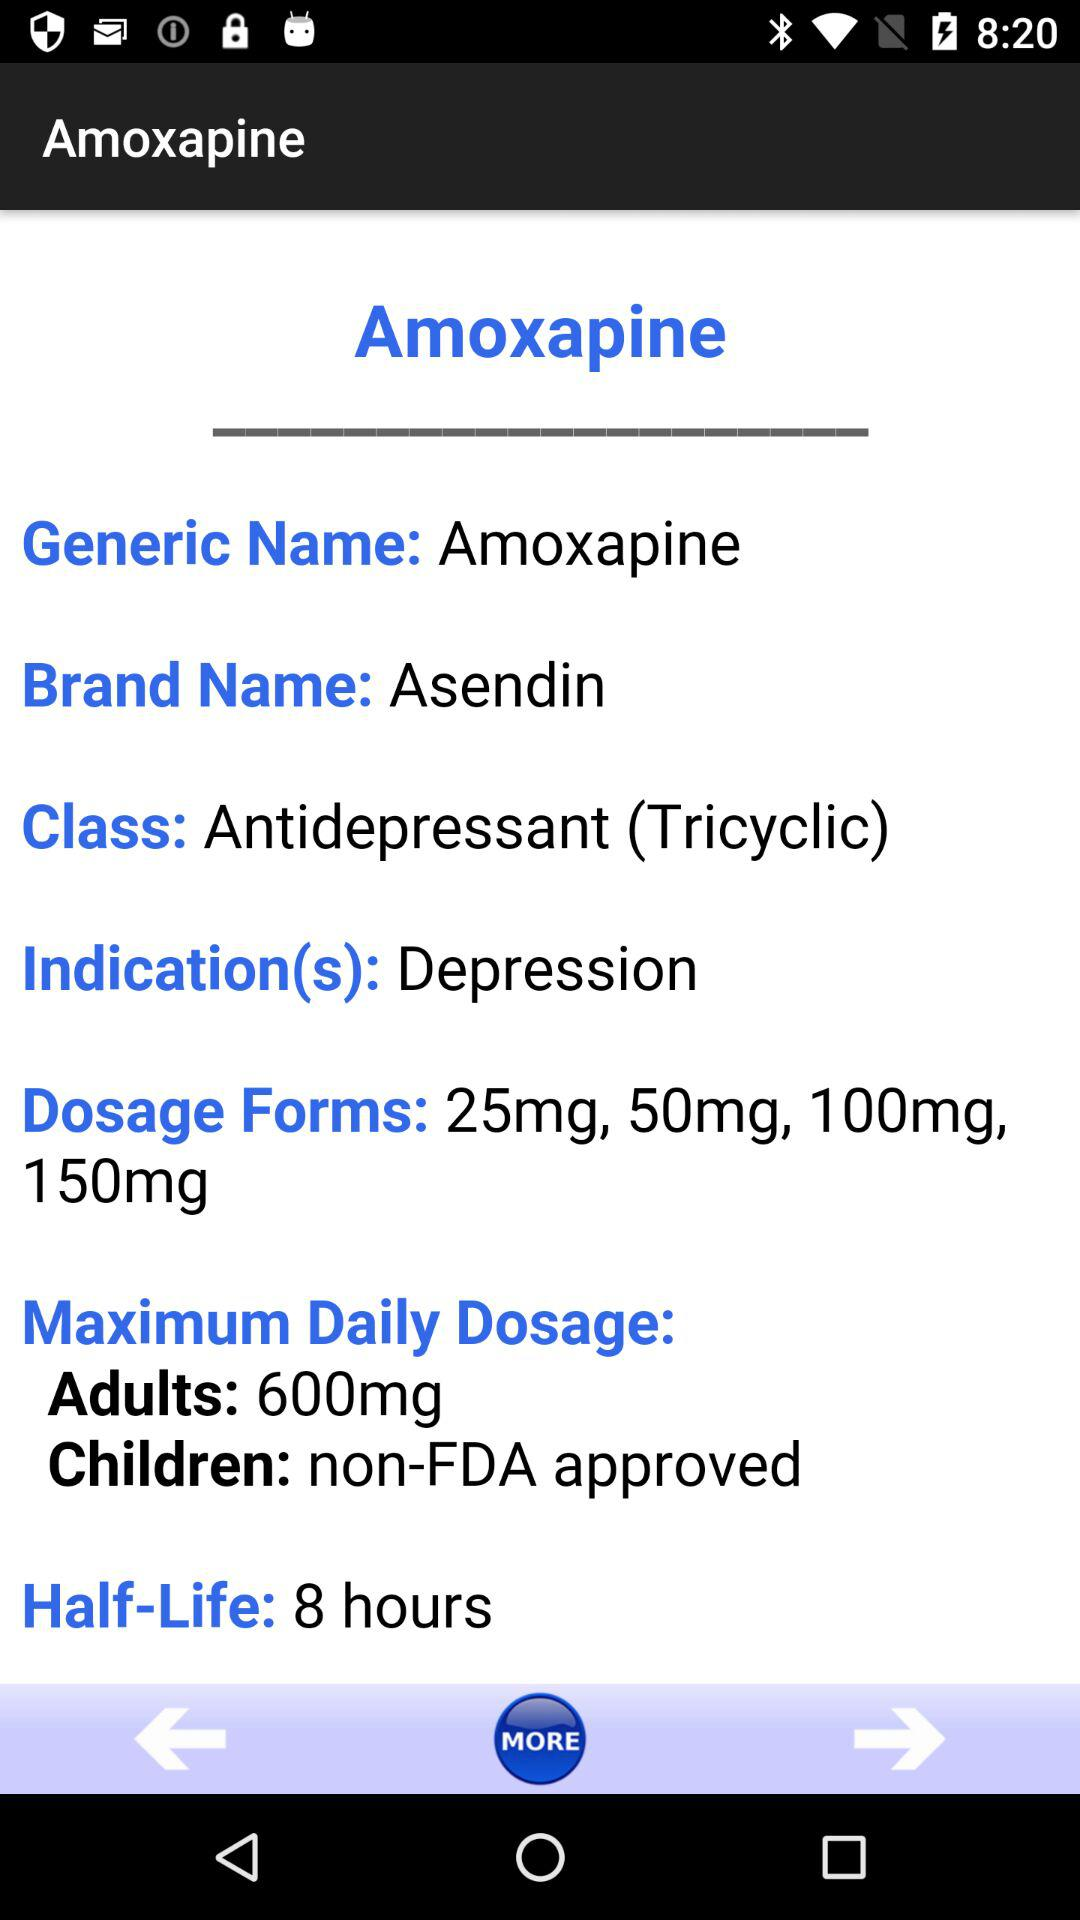What is the brand name? The brand name is "Asendin". 